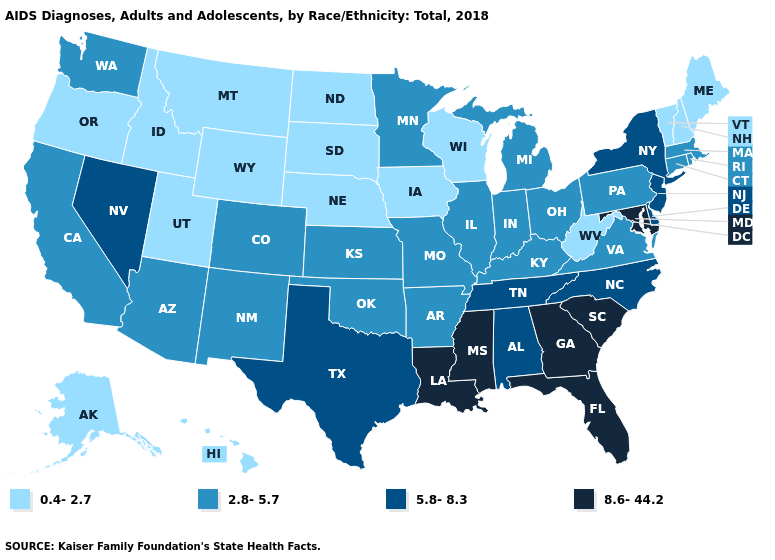Name the states that have a value in the range 2.8-5.7?
Be succinct. Arizona, Arkansas, California, Colorado, Connecticut, Illinois, Indiana, Kansas, Kentucky, Massachusetts, Michigan, Minnesota, Missouri, New Mexico, Ohio, Oklahoma, Pennsylvania, Rhode Island, Virginia, Washington. What is the value of Delaware?
Write a very short answer. 5.8-8.3. What is the lowest value in states that border Kentucky?
Answer briefly. 0.4-2.7. Does Utah have a higher value than Connecticut?
Concise answer only. No. What is the value of Maine?
Short answer required. 0.4-2.7. What is the lowest value in the South?
Concise answer only. 0.4-2.7. Which states have the lowest value in the USA?
Keep it brief. Alaska, Hawaii, Idaho, Iowa, Maine, Montana, Nebraska, New Hampshire, North Dakota, Oregon, South Dakota, Utah, Vermont, West Virginia, Wisconsin, Wyoming. What is the lowest value in the West?
Be succinct. 0.4-2.7. What is the highest value in states that border Illinois?
Be succinct. 2.8-5.7. What is the value of Louisiana?
Be succinct. 8.6-44.2. How many symbols are there in the legend?
Short answer required. 4. What is the lowest value in the USA?
Answer briefly. 0.4-2.7. What is the lowest value in the USA?
Keep it brief. 0.4-2.7. What is the value of Maine?
Answer briefly. 0.4-2.7. Does Washington have a lower value than Colorado?
Be succinct. No. 